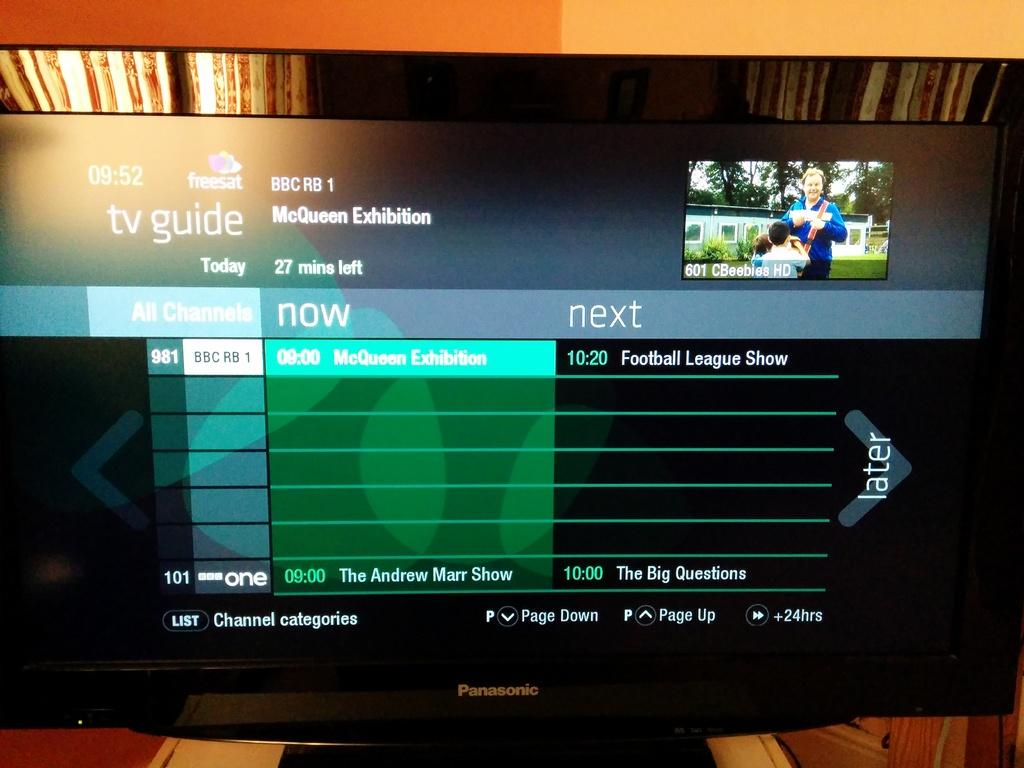<image>
Offer a succinct explanation of the picture presented. a tv guide channel with a show on 